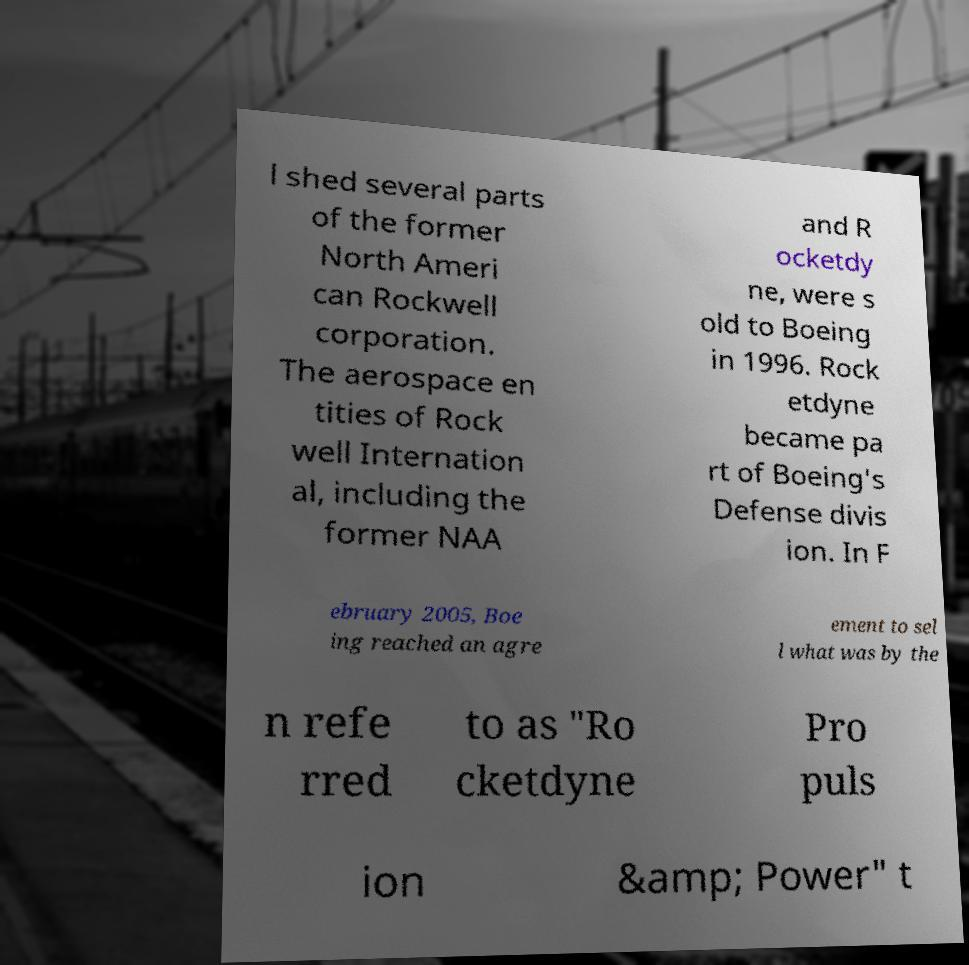Could you extract and type out the text from this image? l shed several parts of the former North Ameri can Rockwell corporation. The aerospace en tities of Rock well Internation al, including the former NAA and R ocketdy ne, were s old to Boeing in 1996. Rock etdyne became pa rt of Boeing's Defense divis ion. In F ebruary 2005, Boe ing reached an agre ement to sel l what was by the n refe rred to as "Ro cketdyne Pro puls ion &amp; Power" t 